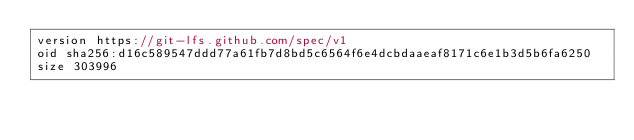Convert code to text. <code><loc_0><loc_0><loc_500><loc_500><_TypeScript_>version https://git-lfs.github.com/spec/v1
oid sha256:d16c589547ddd77a61fb7d8bd5c6564f6e4dcbdaaeaf8171c6e1b3d5b6fa6250
size 303996
</code> 